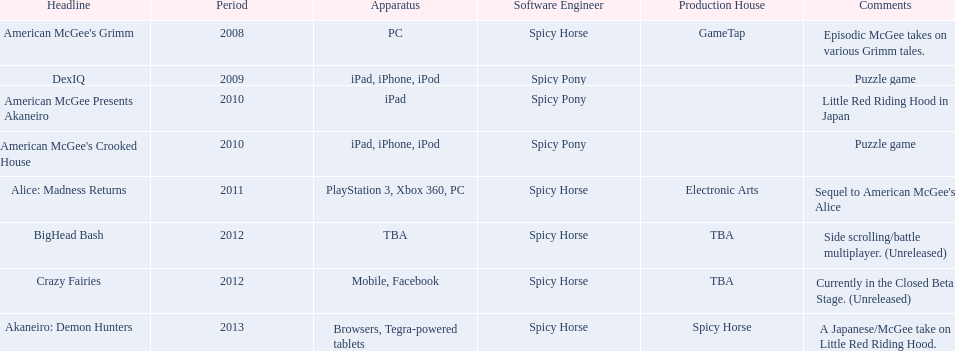How many platforms did american mcgee's grimm run on? 1. 